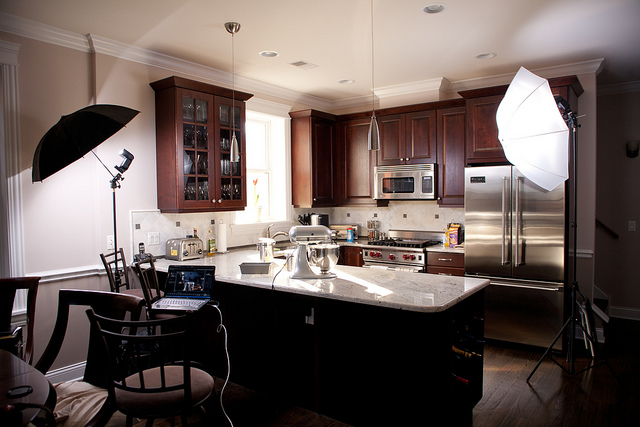<image>If a burglar stole food from the refrigerator, what incriminating evidence might she leave behind? It is hard to tell what evidence a burglar might leave behind. It could be fingerprints, crumbs or an open door. If a burglar stole food from the refrigerator, what incriminating evidence might she leave behind? There could be multiple incriminating evidence that a burglar might leave behind if they stole food from the refrigerator. Some possible evidence could include fingerprints, crumbs, or an open door. However, it is not possible to determine the exact evidence without additional information. 